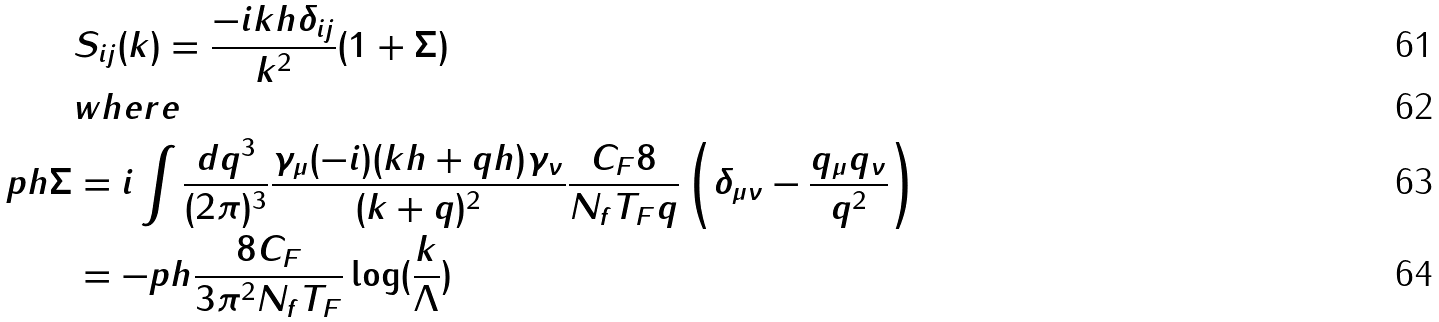Convert formula to latex. <formula><loc_0><loc_0><loc_500><loc_500>& S _ { i j } ( k ) = \frac { - i k \sl h \delta _ { i j } } { k ^ { 2 } } ( 1 + \Sigma ) \\ & w h e r e \\ p \sl h \Sigma & = i \int \frac { d q ^ { 3 } } { ( 2 \pi ) ^ { 3 } } \frac { \gamma _ { \mu } ( - i ) ( k \sl h + q \sl h ) \gamma _ { \nu } } { ( k + q ) ^ { 2 } } \frac { C _ { F } 8 } { N _ { f } T _ { F } q } \left ( \delta _ { \mu \nu } - \frac { q _ { \mu } q _ { \nu } } { q ^ { 2 } } \right ) \\ & = - p \sl h \frac { 8 C _ { F } } { 3 \pi ^ { 2 } N _ { f } T _ { F } } \log ( \frac { k } { \Lambda } )</formula> 